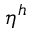<formula> <loc_0><loc_0><loc_500><loc_500>\eta ^ { h }</formula> 